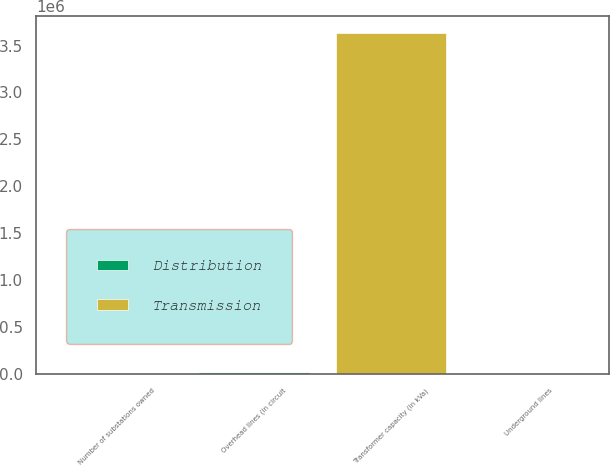Convert chart to OTSL. <chart><loc_0><loc_0><loc_500><loc_500><stacked_bar_chart><ecel><fcel>Number of substations owned<fcel>Transformer capacity (in kVa)<fcel>Overhead lines (in circuit<fcel>Underground lines<nl><fcel>Distribution<fcel>182<fcel>1673<fcel>16955<fcel>6639<nl><fcel>Transmission<fcel>20<fcel>3.633e+06<fcel>1673<fcel>137<nl></chart> 